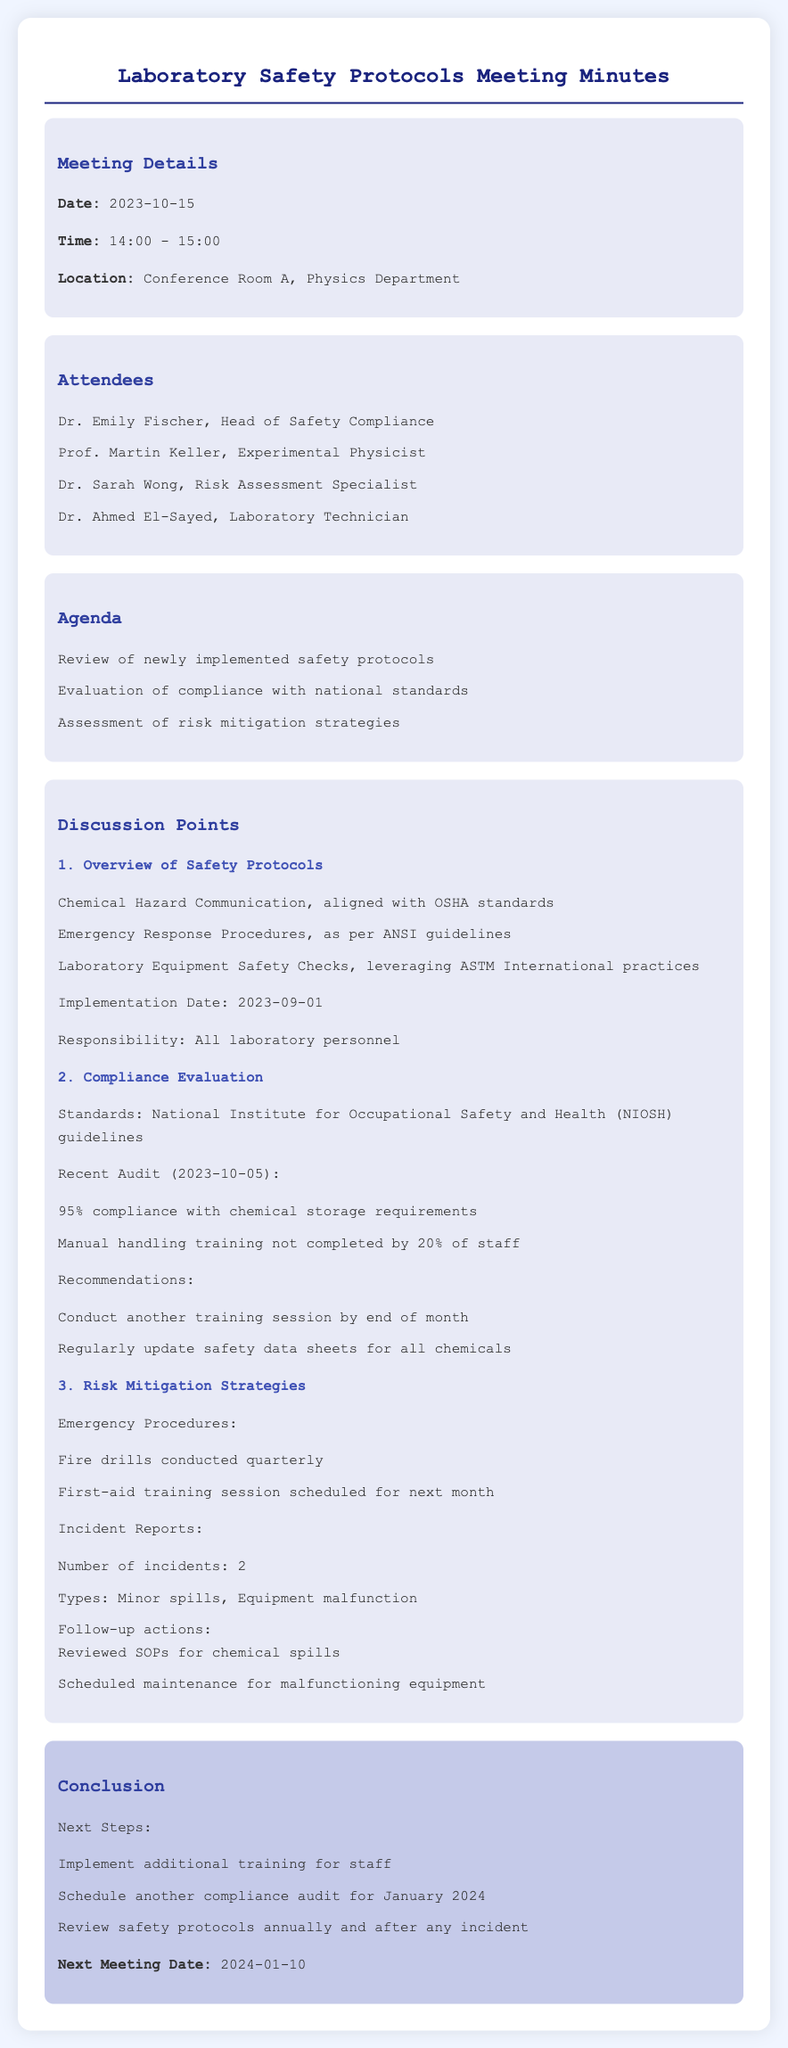What is the date of the meeting? The date of the meeting is stated under "Meeting Details" in the document.
Answer: 2023-10-15 Who is the Head of Safety Compliance? The name of the Head of Safety Compliance is listed in the "Attendees" section.
Answer: Dr. Emily Fischer What percentage of compliance was achieved with chemical storage requirements? The compliance percentage is mentioned in the "Compliance Evaluation" discussion point.
Answer: 95% When is the next scheduled meeting? The date of the next meeting is noted in the "Conclusion" section of the document.
Answer: 2024-01-10 What are the two types of incidents reported? The types of incidents are listed in the "Incident Reports" under "Risk Mitigation Strategies."
Answer: Minor spills, Equipment malfunction What is the implementation date of the safety protocols? The implementation date is specified in the "Overview of Safety Protocols."
Answer: 2023-09-01 What recommendation was made regarding manual handling training? The recommendation is found in the "Compliance Evaluation" discussion point.
Answer: Conduct another training session by end of month How often are fire drills conducted? The frequency of fire drills is mentioned under "Risk Mitigation Strategies."
Answer: Quarterly 